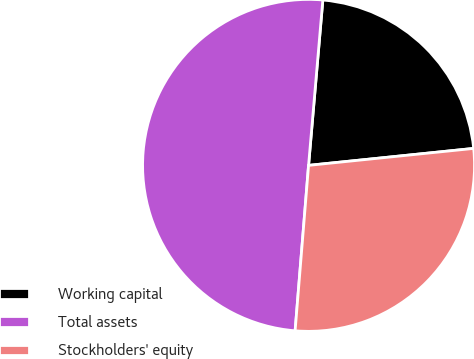Convert chart to OTSL. <chart><loc_0><loc_0><loc_500><loc_500><pie_chart><fcel>Working capital<fcel>Total assets<fcel>Stockholders' equity<nl><fcel>22.0%<fcel>50.08%<fcel>27.92%<nl></chart> 